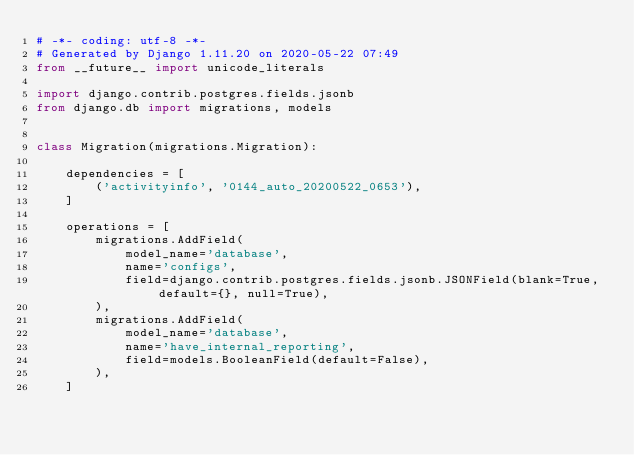<code> <loc_0><loc_0><loc_500><loc_500><_Python_># -*- coding: utf-8 -*-
# Generated by Django 1.11.20 on 2020-05-22 07:49
from __future__ import unicode_literals

import django.contrib.postgres.fields.jsonb
from django.db import migrations, models


class Migration(migrations.Migration):

    dependencies = [
        ('activityinfo', '0144_auto_20200522_0653'),
    ]

    operations = [
        migrations.AddField(
            model_name='database',
            name='configs',
            field=django.contrib.postgres.fields.jsonb.JSONField(blank=True, default={}, null=True),
        ),
        migrations.AddField(
            model_name='database',
            name='have_internal_reporting',
            field=models.BooleanField(default=False),
        ),
    ]
</code> 